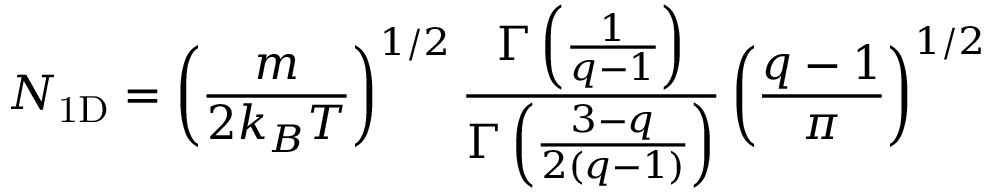Convert formula to latex. <formula><loc_0><loc_0><loc_500><loc_500>N _ { 1 D } = \left ( \frac { m } { 2 k _ { B } T } \right ) ^ { 1 / 2 } \frac { \Gamma \left ( \frac { 1 } { q - 1 } \right ) } { \Gamma \left ( \frac { 3 - q } { 2 \left ( q - 1 \right ) } \right ) } \left ( \frac { q - 1 } { \pi } \right ) ^ { 1 / 2 }</formula> 